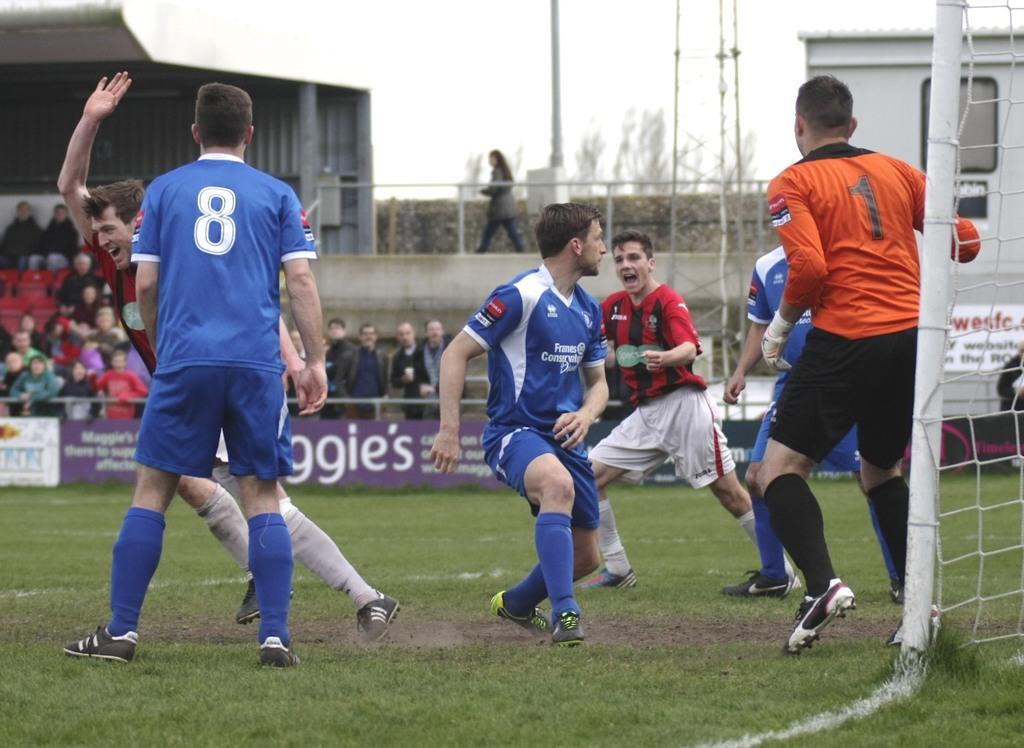Provide a one-sentence caption for the provided image. The soccer player on the left has the number 8 on his jersey. 